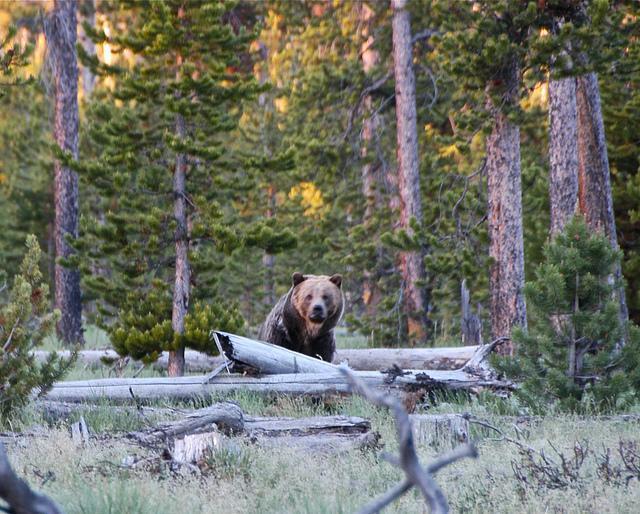How many bears are here?
Give a very brief answer. 1. 